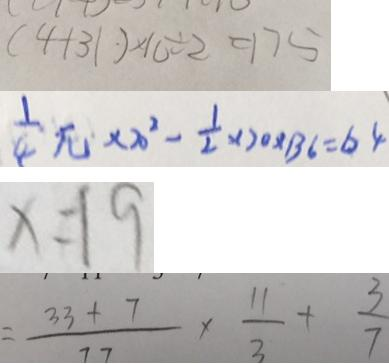Convert formula to latex. <formula><loc_0><loc_0><loc_500><loc_500>( 4 + 3 1 ) \times 1 0 \div 2 = 1 7 5 
 \frac { 1 } { 4 } \pi \times 2 0 ^ { 2 } - \frac { 1 } { 2 } \times 2 0 \times 1 3 6 = 6 4 
 x = 1 9 
 = \frac { 3 3 + 7 } { 7 7 } \times \frac { 1 1 } { 3 } + \frac { 3 } { 7 }</formula> 